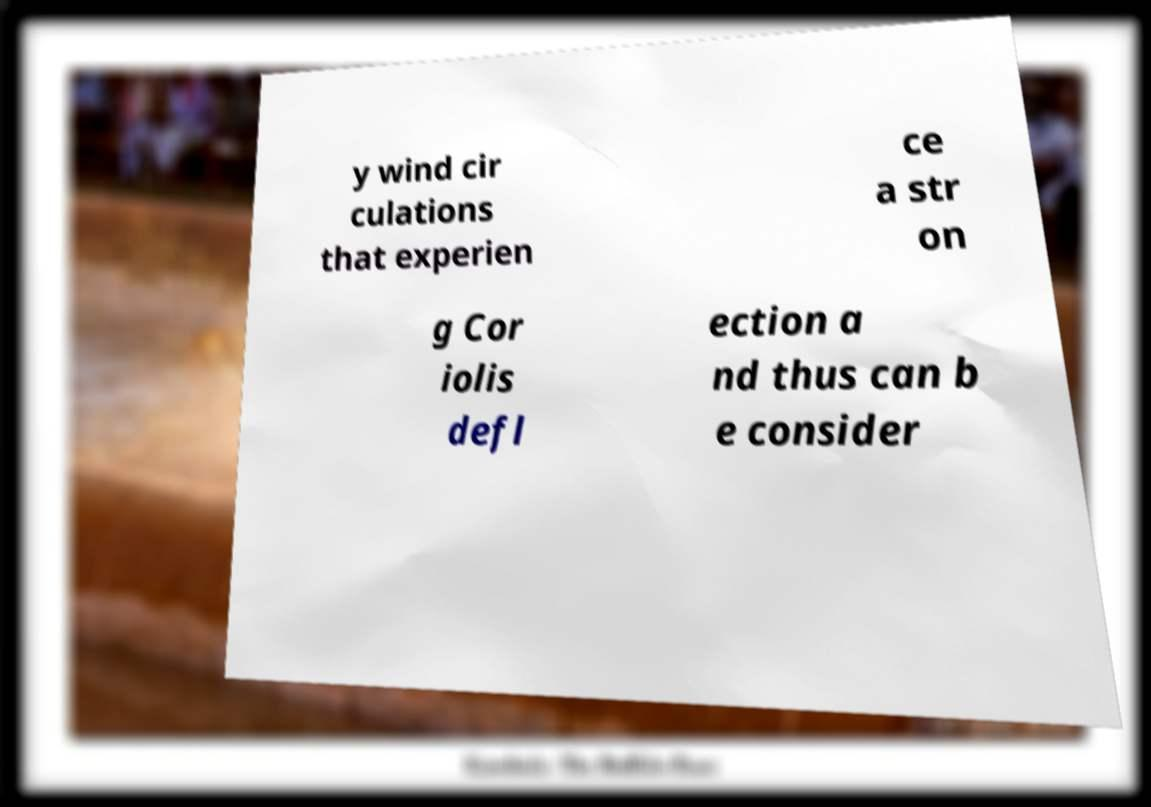Could you assist in decoding the text presented in this image and type it out clearly? y wind cir culations that experien ce a str on g Cor iolis defl ection a nd thus can b e consider 